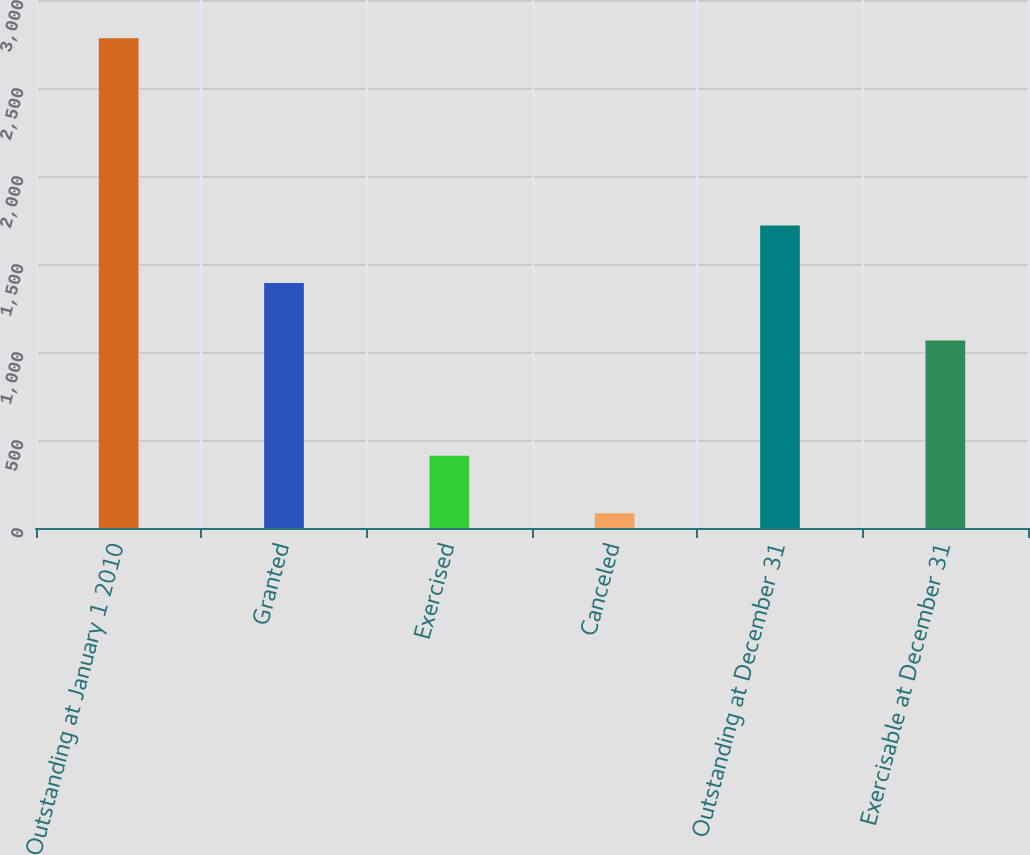Convert chart to OTSL. <chart><loc_0><loc_0><loc_500><loc_500><bar_chart><fcel>Outstanding at January 1 2010<fcel>Granted<fcel>Exercised<fcel>Canceled<fcel>Outstanding at December 31<fcel>Exercisable at December 31<nl><fcel>2782<fcel>1391.6<fcel>410.9<fcel>84<fcel>1718.5<fcel>1064.7<nl></chart> 